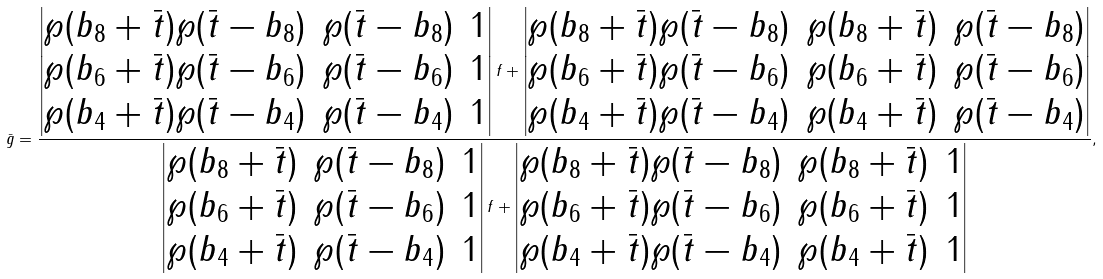<formula> <loc_0><loc_0><loc_500><loc_500>\bar { g } = \frac { \begin{vmatrix} \wp ( b _ { 8 } + \bar { t } ) \wp ( \bar { t } - b _ { 8 } ) & \wp ( \bar { t } - b _ { 8 } ) & 1 \\ \wp ( b _ { 6 } + \bar { t } ) \wp ( \bar { t } - b _ { 6 } ) & \wp ( \bar { t } - b _ { 6 } ) & 1 \\ \wp ( b _ { 4 } + \bar { t } ) \wp ( \bar { t } - b _ { 4 } ) & \wp ( \bar { t } - b _ { 4 } ) & 1 \end{vmatrix} f + \begin{vmatrix} \wp ( b _ { 8 } + \bar { t } ) \wp ( \bar { t } - b _ { 8 } ) & \wp ( b _ { 8 } + \bar { t } ) & \wp ( \bar { t } - b _ { 8 } ) \\ \wp ( b _ { 6 } + \bar { t } ) \wp ( \bar { t } - b _ { 6 } ) & \wp ( b _ { 6 } + \bar { t } ) & \wp ( \bar { t } - b _ { 6 } ) \\ \wp ( b _ { 4 } + \bar { t } ) \wp ( \bar { t } - b _ { 4 } ) & \wp ( b _ { 4 } + \bar { t } ) & \wp ( \bar { t } - b _ { 4 } ) \end{vmatrix} } { \begin{vmatrix} \wp ( b _ { 8 } + \bar { t } ) & \wp ( \bar { t } - b _ { 8 } ) & 1 \\ \wp ( b _ { 6 } + \bar { t } ) & \wp ( \bar { t } - b _ { 6 } ) & 1 \\ \wp ( b _ { 4 } + \bar { t } ) & \wp ( \bar { t } - b _ { 4 } ) & 1 \end{vmatrix} f + \begin{vmatrix} \wp ( b _ { 8 } + \bar { t } ) \wp ( \bar { t } - b _ { 8 } ) & \wp ( b _ { 8 } + \bar { t } ) & 1 \\ \wp ( b _ { 6 } + \bar { t } ) \wp ( \bar { t } - b _ { 6 } ) & \wp ( b _ { 6 } + \bar { t } ) & 1 \\ \wp ( b _ { 4 } + \bar { t } ) \wp ( \bar { t } - b _ { 4 } ) & \wp ( b _ { 4 } + \bar { t } ) & 1 \end{vmatrix} } ,</formula> 